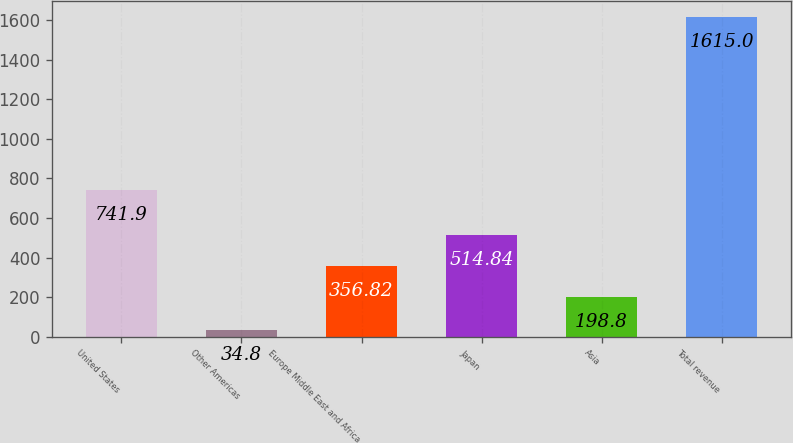Convert chart to OTSL. <chart><loc_0><loc_0><loc_500><loc_500><bar_chart><fcel>United States<fcel>Other Americas<fcel>Europe Middle East and Africa<fcel>Japan<fcel>Asia<fcel>Total revenue<nl><fcel>741.9<fcel>34.8<fcel>356.82<fcel>514.84<fcel>198.8<fcel>1615<nl></chart> 